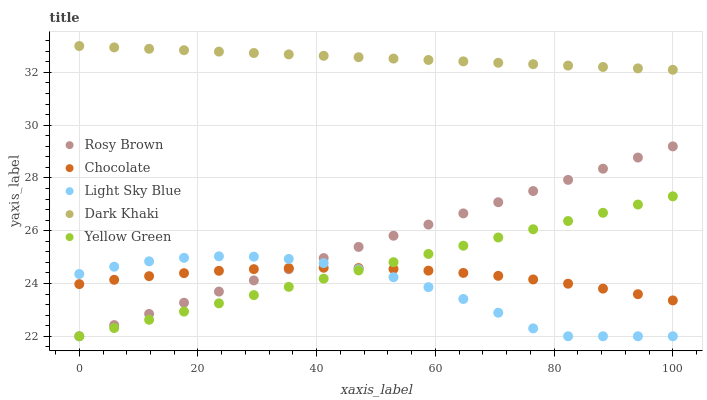Does Light Sky Blue have the minimum area under the curve?
Answer yes or no. Yes. Does Dark Khaki have the maximum area under the curve?
Answer yes or no. Yes. Does Rosy Brown have the minimum area under the curve?
Answer yes or no. No. Does Rosy Brown have the maximum area under the curve?
Answer yes or no. No. Is Dark Khaki the smoothest?
Answer yes or no. Yes. Is Light Sky Blue the roughest?
Answer yes or no. Yes. Is Rosy Brown the smoothest?
Answer yes or no. No. Is Rosy Brown the roughest?
Answer yes or no. No. Does Rosy Brown have the lowest value?
Answer yes or no. Yes. Does Chocolate have the lowest value?
Answer yes or no. No. Does Dark Khaki have the highest value?
Answer yes or no. Yes. Does Rosy Brown have the highest value?
Answer yes or no. No. Is Rosy Brown less than Dark Khaki?
Answer yes or no. Yes. Is Dark Khaki greater than Yellow Green?
Answer yes or no. Yes. Does Light Sky Blue intersect Chocolate?
Answer yes or no. Yes. Is Light Sky Blue less than Chocolate?
Answer yes or no. No. Is Light Sky Blue greater than Chocolate?
Answer yes or no. No. Does Rosy Brown intersect Dark Khaki?
Answer yes or no. No. 